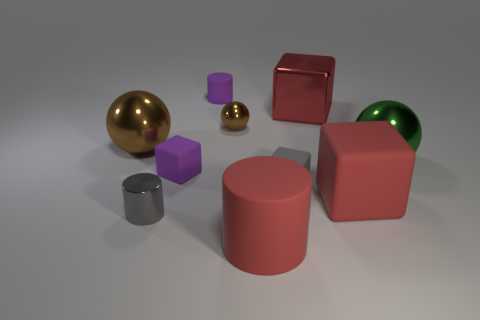Is there a yellow matte ball?
Make the answer very short. No. There is another large thing that is the same shape as the large brown metal thing; what is its material?
Keep it short and to the point. Metal. There is a gray cylinder; are there any brown metallic objects right of it?
Your response must be concise. Yes. Do the brown sphere on the right side of the big brown metal ball and the large cylinder have the same material?
Give a very brief answer. No. Are there any metal objects of the same color as the tiny ball?
Provide a succinct answer. Yes. There is a green thing; what shape is it?
Your response must be concise. Sphere. The big sphere right of the metallic thing that is left of the small gray shiny cylinder is what color?
Give a very brief answer. Green. There is a thing that is left of the tiny gray metallic thing; what is its size?
Your answer should be compact. Large. Are there any small things that have the same material as the large cylinder?
Give a very brief answer. Yes. How many big green shiny things are the same shape as the tiny brown thing?
Your answer should be compact. 1. 